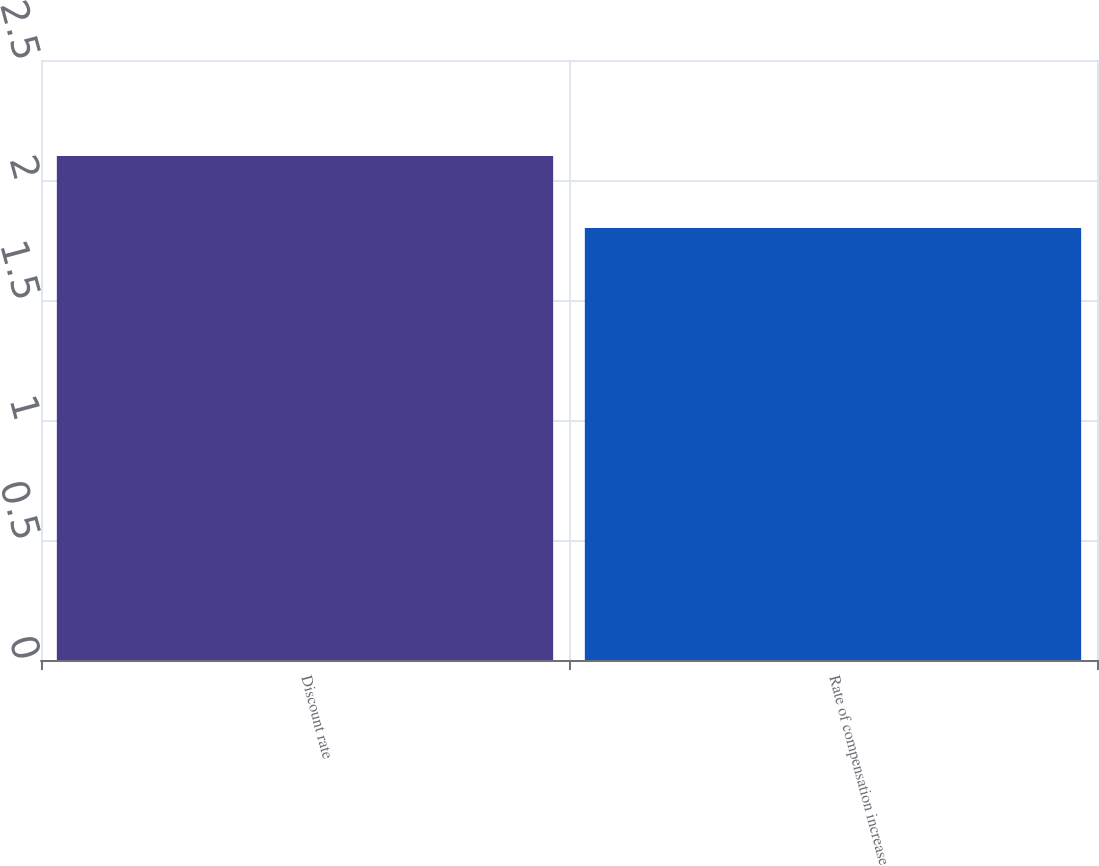<chart> <loc_0><loc_0><loc_500><loc_500><bar_chart><fcel>Discount rate<fcel>Rate of compensation increase<nl><fcel>2.1<fcel>1.8<nl></chart> 